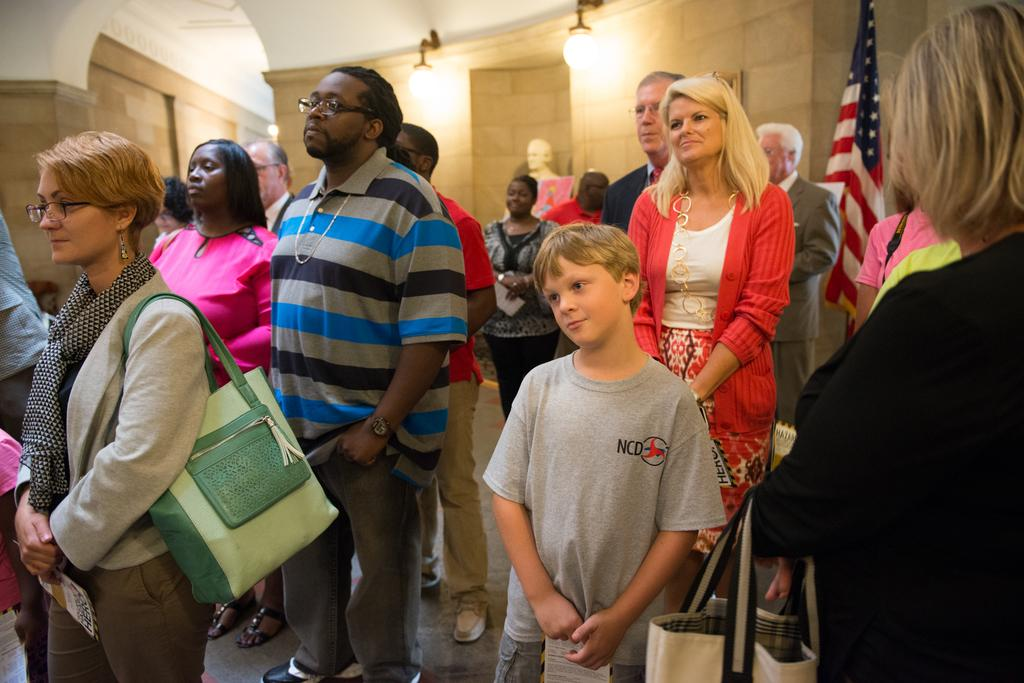How many people are present in the image? There are people in the image, but the exact number is not specified. What can be seen in the image besides people? There is a flag, lights, a statue, walls, and objects in the image. What are the people holding in the image? Some people are holding objects in the image. What are the two people wearing in the image? Two people are wearing bags in the image. What is the people's learning progress in the image? There is no information about the people's learning progress in the image. How much loss can be observed in the image? There is no indication of loss in the image. 